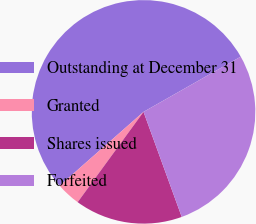Convert chart. <chart><loc_0><loc_0><loc_500><loc_500><pie_chart><fcel>Outstanding at December 31<fcel>Granted<fcel>Shares issued<fcel>Forfeited<nl><fcel>53.27%<fcel>3.48%<fcel>15.58%<fcel>27.67%<nl></chart> 